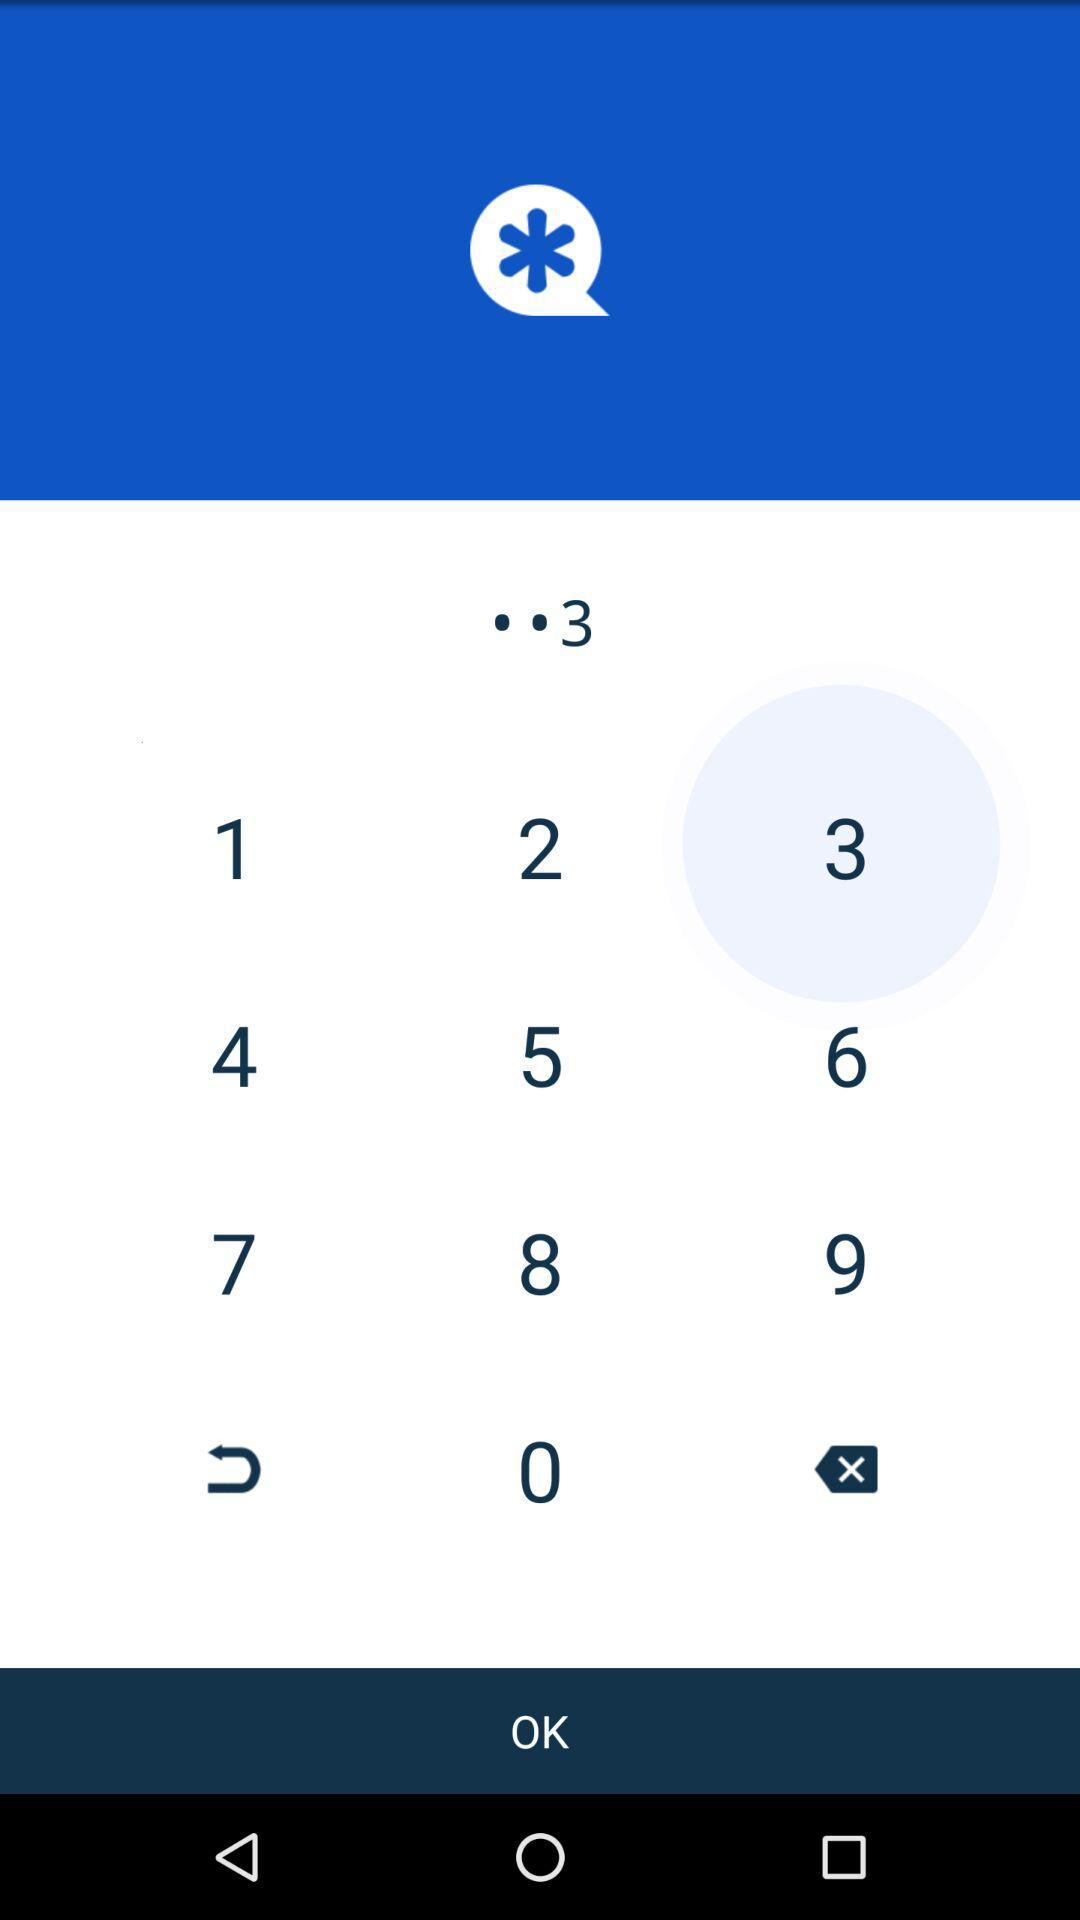What is the passcode's last digit? The last digit is 3. 